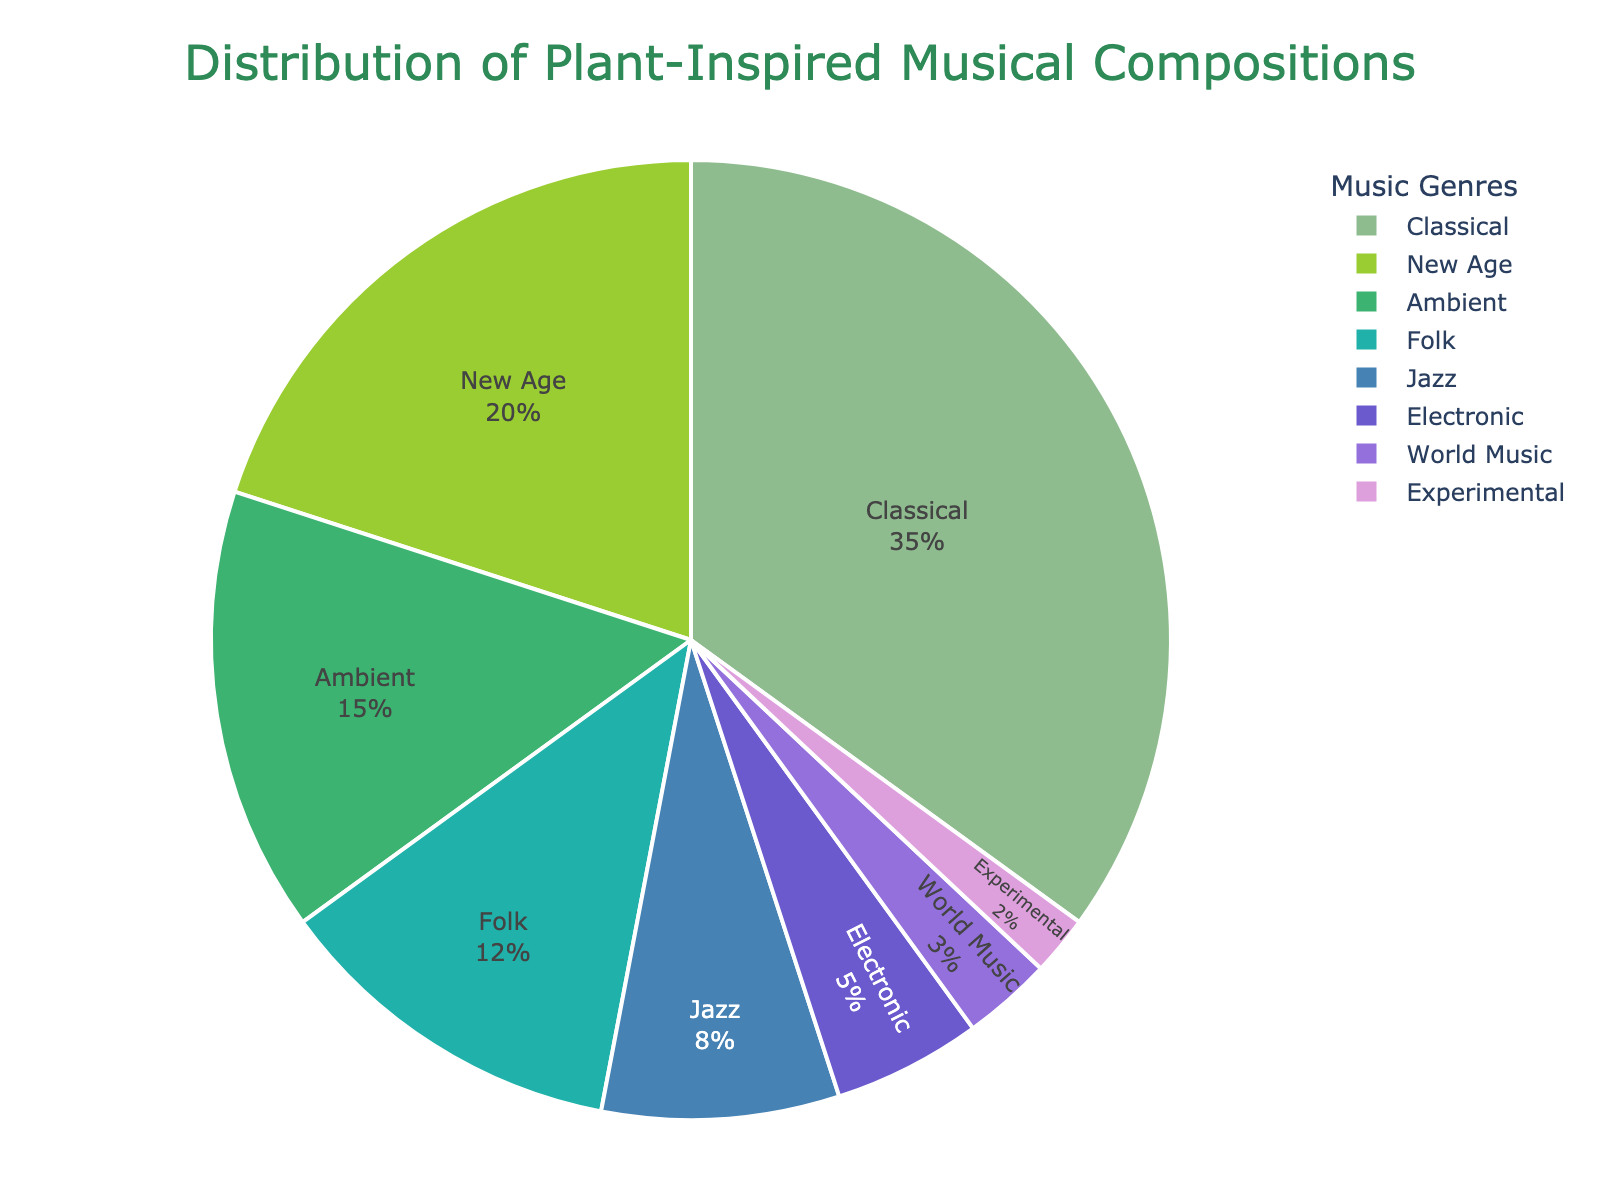what genre has the highest percentage of plant-inspired musical compositions? The pie chart shows the proportional distribution of different genres. The genre with the largest segment represents the highest percentage. This is visible through the size of the segment.
Answer: Classical what percentage of plant-inspired compositions are in the Jazz genre? Look for the segment labeled Jazz in the pie chart. The percentage is written inside or near the segment.
Answer: 8% What is the combined percentage of Folk, Jazz, and World Music genres? Add the percentages of Folk, Jazz, and World Music as shown in the pie chart. Folk is 12%, Jazz is 8%, and World Music is 3%. The sum is 12 + 8 + 3 = 23%.
Answer: 23% Which has a higher percentage: New Age or Ambient? Compare the size of the segments and their corresponding percentages. New Age is 20% and Ambient is 15%.
Answer: New Age What is the total percentage of genres that have less than 10%? Sum the percentages of all genres that have less than 10%: Jazz (8%), Electronic (5%), World Music (3%), Experimental (2%). The sum is 8 + 5 + 3 + 2 = 18%.
Answer: 18% Is Classical genre more than half of the total compositions compared to New Age and Ambient combined? First calculate the total of New Age and Ambient combined: 20% + 15% = 35%. Compare Classical's percentage (35%) to this calculated value. Since 35% is equal to 35%, it is not more than half of 35%.
Answer: No What is the difference in percentage between the highest and lowest genres? Identify the highest and lowest percentages from the pie chart: Classical (35%) and Experimental (2%). Calculate the difference: 35% - 2% = 33%.
Answer: 33% Which genre has a percentage closest to but not exceeding 10%? Examine the percentages in the pie chart and identify the one closest to 10% without exceeding it. Jazz has 8%, which is the closest without exceeding.
Answer: Jazz What are the two genres with the least percentage and their combined percentage? Identify the two smallest segments in the chart: World Music (3%) and Experimental (2%). Add their percentages: 3% + 2% = 5%.
Answer: World Music and Experimental; 5% How much more percentage does Classical have compared to Electronic? Identify the percentages for Classical (35%) and Electronic (5%) and subtract Electronic’s percentage from Classical’s (35% - 5% = 30%).
Answer: 30% 